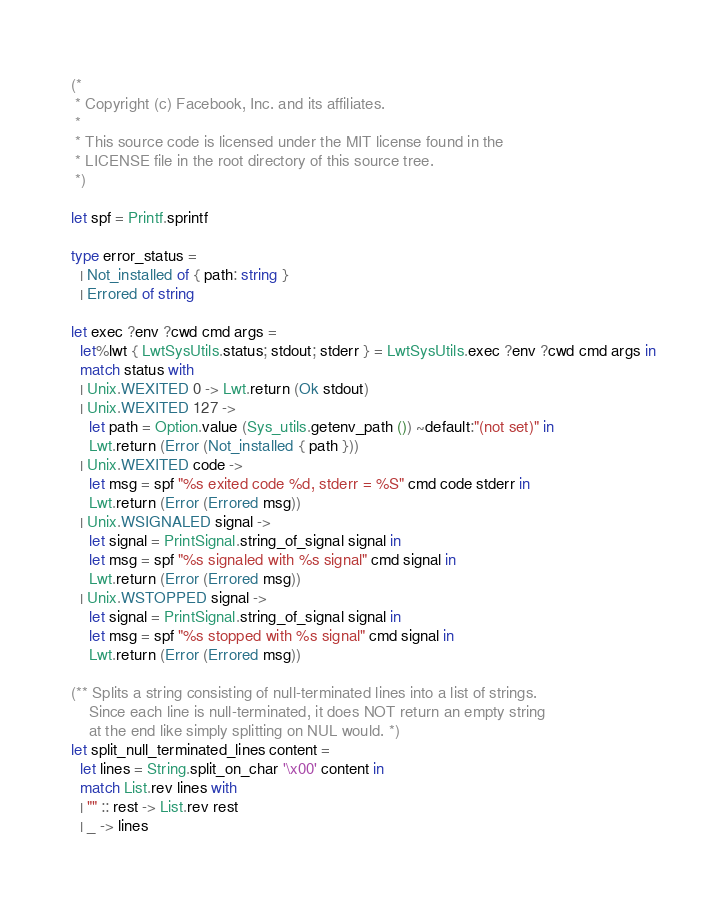Convert code to text. <code><loc_0><loc_0><loc_500><loc_500><_OCaml_>(*
 * Copyright (c) Facebook, Inc. and its affiliates.
 *
 * This source code is licensed under the MIT license found in the
 * LICENSE file in the root directory of this source tree.
 *)

let spf = Printf.sprintf

type error_status =
  | Not_installed of { path: string }
  | Errored of string

let exec ?env ?cwd cmd args =
  let%lwt { LwtSysUtils.status; stdout; stderr } = LwtSysUtils.exec ?env ?cwd cmd args in
  match status with
  | Unix.WEXITED 0 -> Lwt.return (Ok stdout)
  | Unix.WEXITED 127 ->
    let path = Option.value (Sys_utils.getenv_path ()) ~default:"(not set)" in
    Lwt.return (Error (Not_installed { path }))
  | Unix.WEXITED code ->
    let msg = spf "%s exited code %d, stderr = %S" cmd code stderr in
    Lwt.return (Error (Errored msg))
  | Unix.WSIGNALED signal ->
    let signal = PrintSignal.string_of_signal signal in
    let msg = spf "%s signaled with %s signal" cmd signal in
    Lwt.return (Error (Errored msg))
  | Unix.WSTOPPED signal ->
    let signal = PrintSignal.string_of_signal signal in
    let msg = spf "%s stopped with %s signal" cmd signal in
    Lwt.return (Error (Errored msg))

(** Splits a string consisting of null-terminated lines into a list of strings.
    Since each line is null-terminated, it does NOT return an empty string
    at the end like simply splitting on NUL would. *)
let split_null_terminated_lines content =
  let lines = String.split_on_char '\x00' content in
  match List.rev lines with
  | "" :: rest -> List.rev rest
  | _ -> lines
</code> 